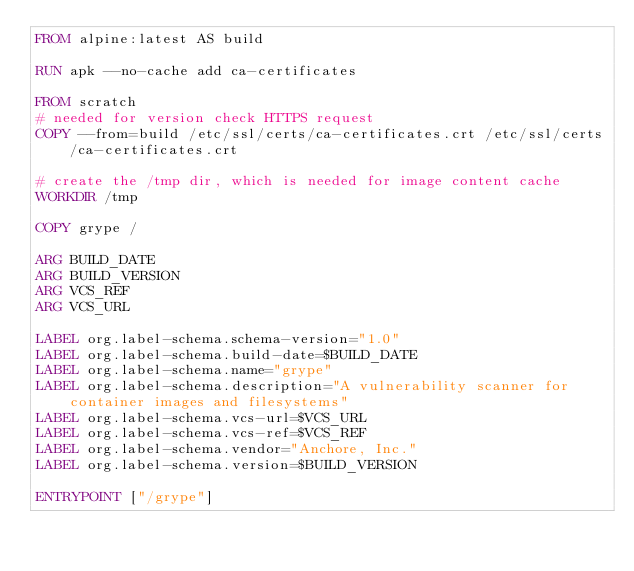<code> <loc_0><loc_0><loc_500><loc_500><_Dockerfile_>FROM alpine:latest AS build

RUN apk --no-cache add ca-certificates

FROM scratch
# needed for version check HTTPS request
COPY --from=build /etc/ssl/certs/ca-certificates.crt /etc/ssl/certs/ca-certificates.crt

# create the /tmp dir, which is needed for image content cache
WORKDIR /tmp

COPY grype /

ARG BUILD_DATE
ARG BUILD_VERSION
ARG VCS_REF
ARG VCS_URL

LABEL org.label-schema.schema-version="1.0"
LABEL org.label-schema.build-date=$BUILD_DATE
LABEL org.label-schema.name="grype"
LABEL org.label-schema.description="A vulnerability scanner for container images and filesystems"
LABEL org.label-schema.vcs-url=$VCS_URL
LABEL org.label-schema.vcs-ref=$VCS_REF
LABEL org.label-schema.vendor="Anchore, Inc."
LABEL org.label-schema.version=$BUILD_VERSION

ENTRYPOINT ["/grype"]</code> 